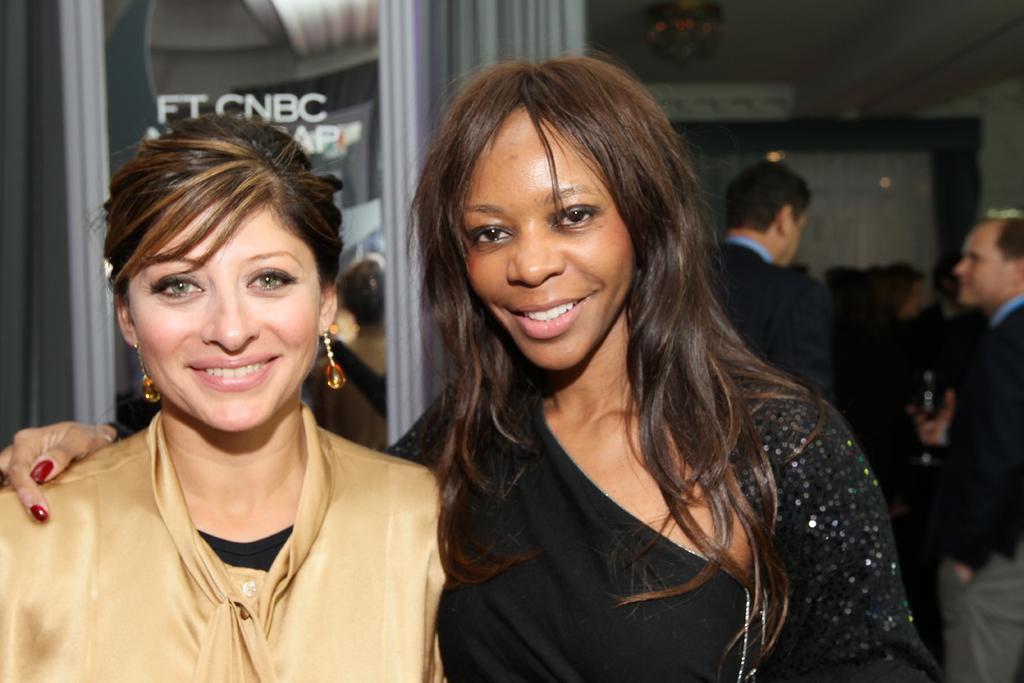Can you describe this image briefly? In this image, we can see two women standing, in the background there are some people standing. 